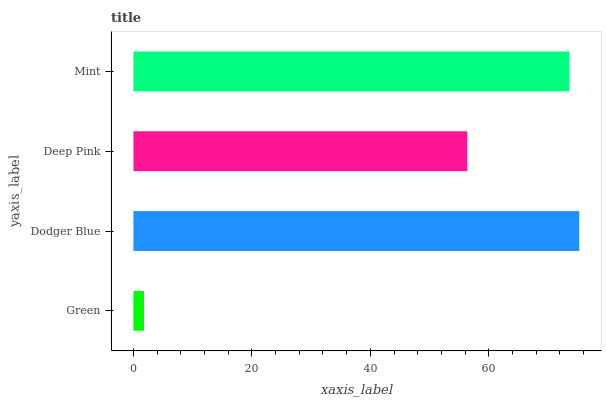Is Green the minimum?
Answer yes or no. Yes. Is Dodger Blue the maximum?
Answer yes or no. Yes. Is Deep Pink the minimum?
Answer yes or no. No. Is Deep Pink the maximum?
Answer yes or no. No. Is Dodger Blue greater than Deep Pink?
Answer yes or no. Yes. Is Deep Pink less than Dodger Blue?
Answer yes or no. Yes. Is Deep Pink greater than Dodger Blue?
Answer yes or no. No. Is Dodger Blue less than Deep Pink?
Answer yes or no. No. Is Mint the high median?
Answer yes or no. Yes. Is Deep Pink the low median?
Answer yes or no. Yes. Is Dodger Blue the high median?
Answer yes or no. No. Is Dodger Blue the low median?
Answer yes or no. No. 